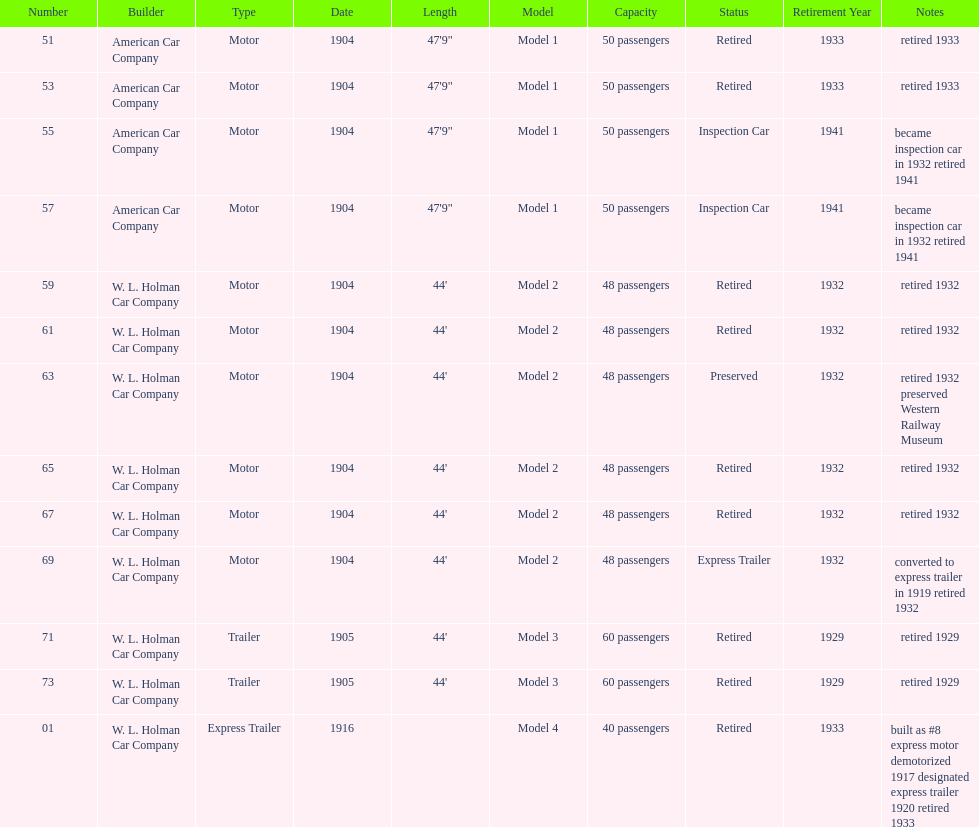In 1906, how many total rolling stock vehicles were in service? 12. 